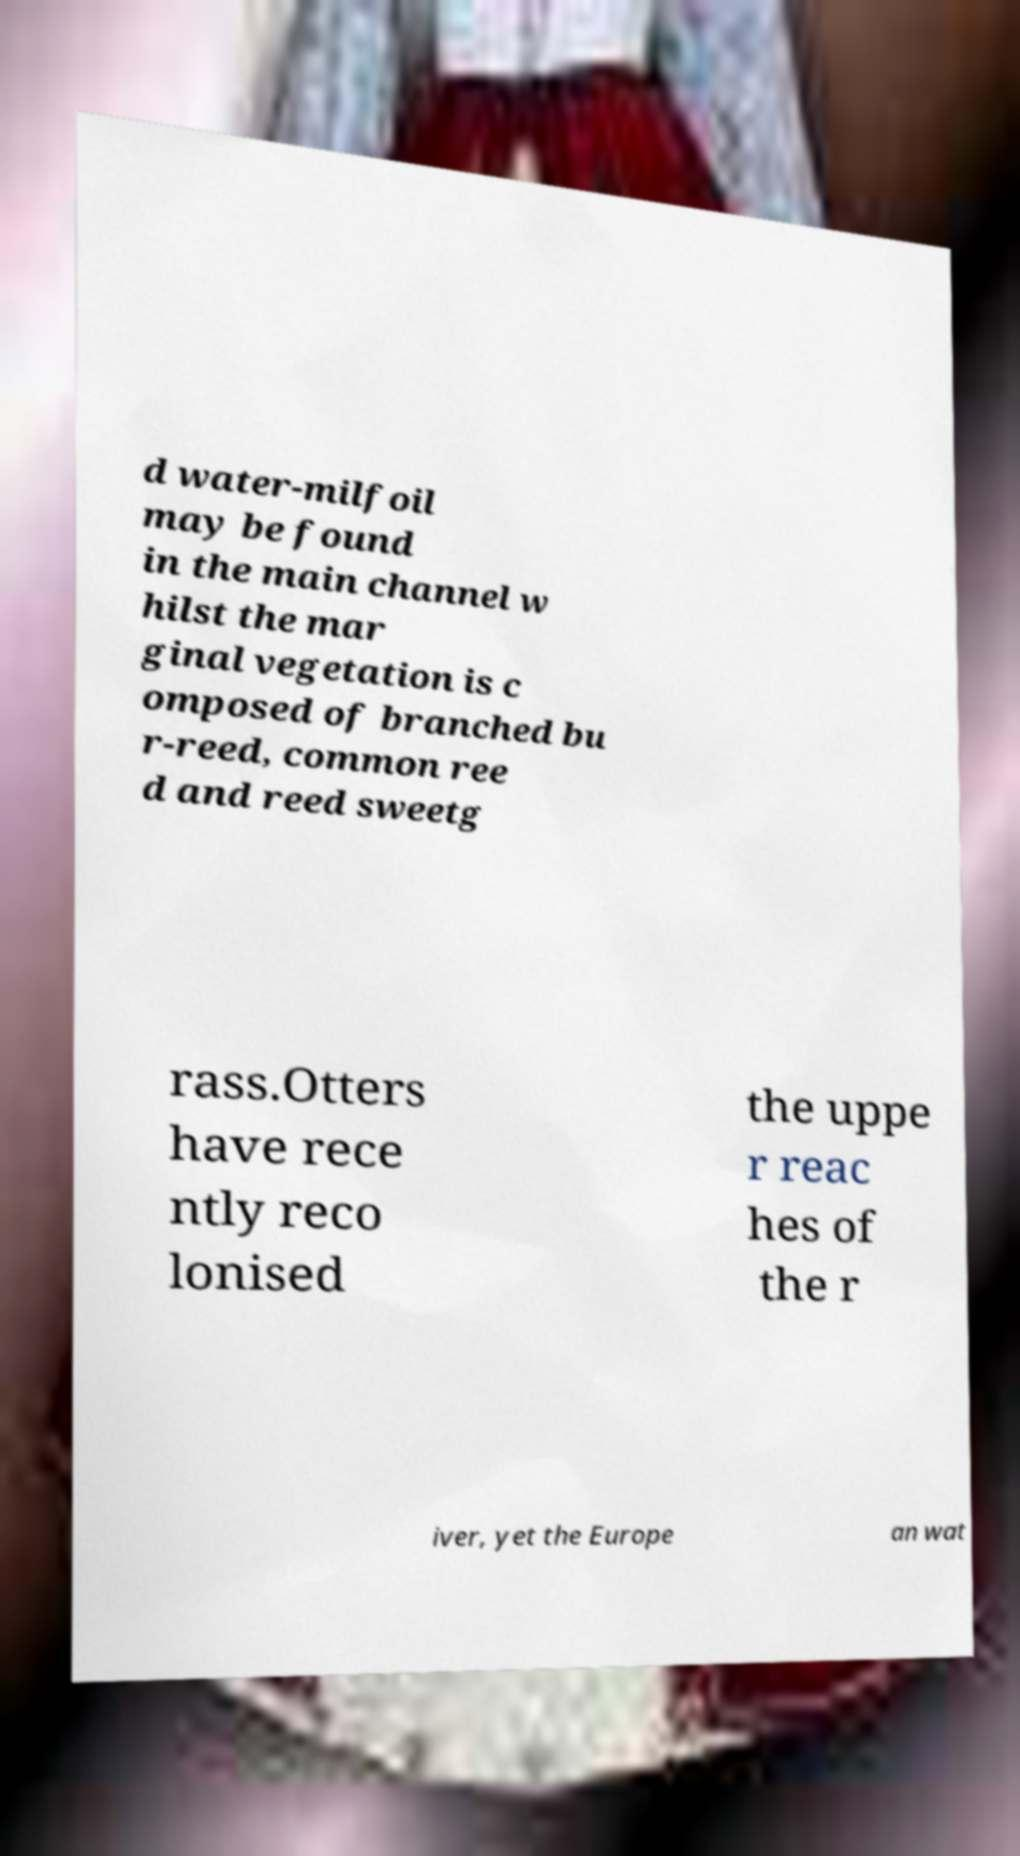Can you read and provide the text displayed in the image?This photo seems to have some interesting text. Can you extract and type it out for me? d water-milfoil may be found in the main channel w hilst the mar ginal vegetation is c omposed of branched bu r-reed, common ree d and reed sweetg rass.Otters have rece ntly reco lonised the uppe r reac hes of the r iver, yet the Europe an wat 